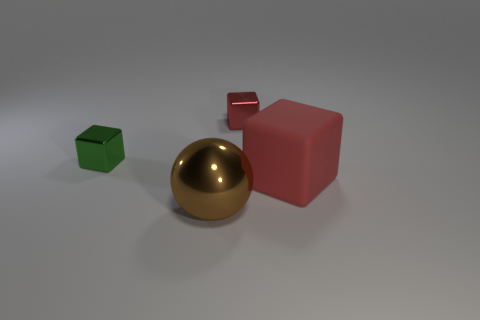Add 1 large red matte things. How many objects exist? 5 Subtract all cubes. How many objects are left? 1 Add 2 brown balls. How many brown balls are left? 3 Add 4 tiny yellow things. How many tiny yellow things exist? 4 Subtract 0 gray cubes. How many objects are left? 4 Subtract all small gray rubber blocks. Subtract all tiny red cubes. How many objects are left? 3 